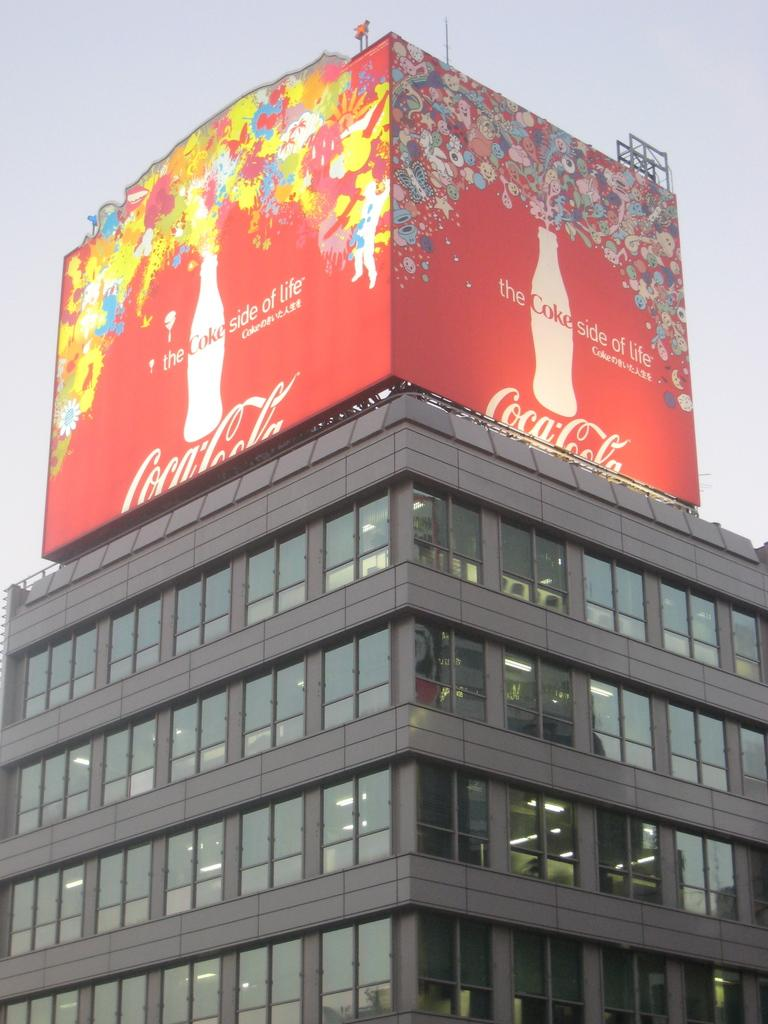What is the main subject in the foreground of the image? There is a building in the foreground of the image. What can be seen above the building in the image? There is a Coca-Cola poster above the building. Where is the rabbit located in the image? There is no rabbit present in the image. What color is the lipstick on the person in the image? There are no people or lipstick visible in the image. 